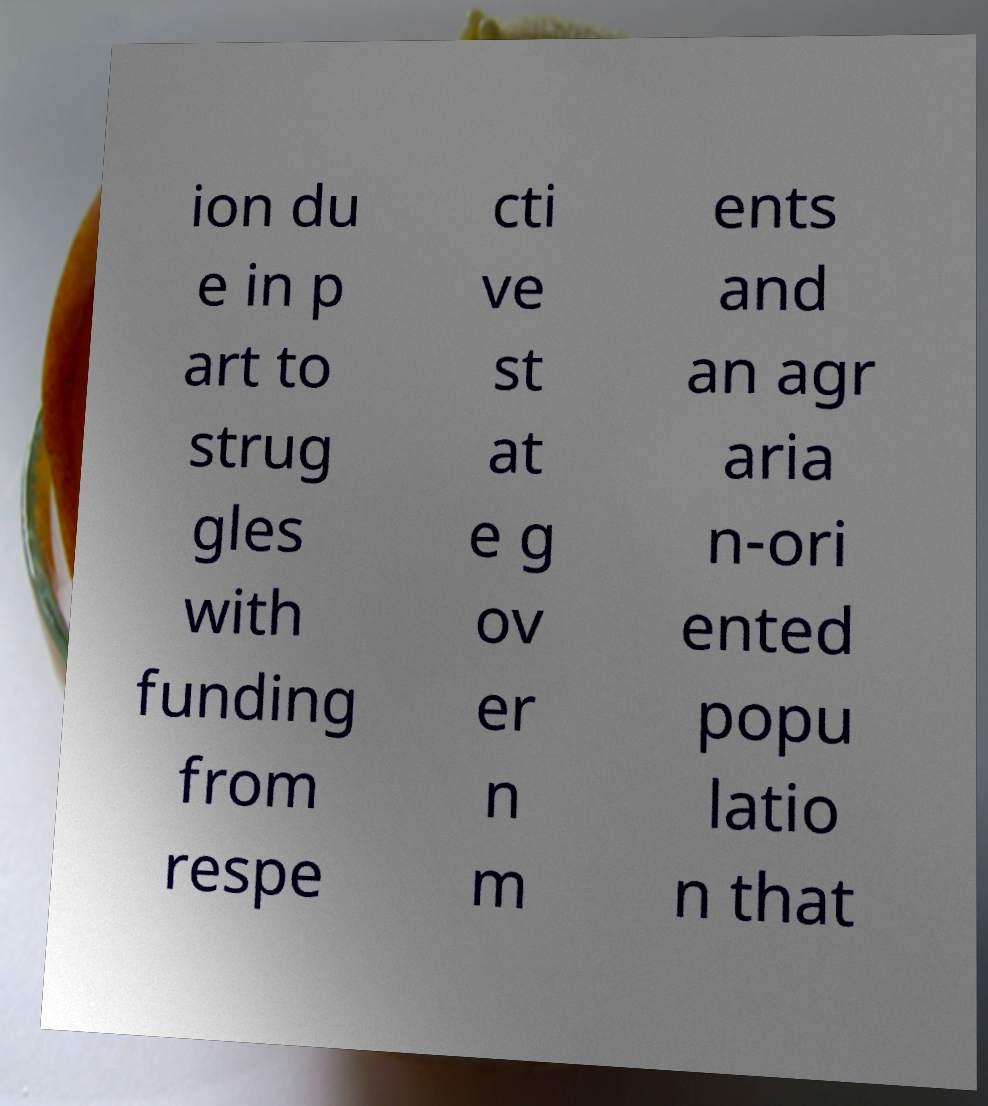Can you read and provide the text displayed in the image?This photo seems to have some interesting text. Can you extract and type it out for me? ion du e in p art to strug gles with funding from respe cti ve st at e g ov er n m ents and an agr aria n-ori ented popu latio n that 